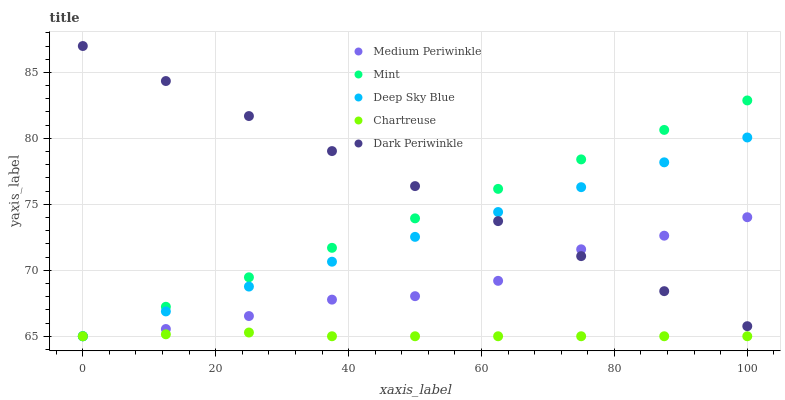Does Chartreuse have the minimum area under the curve?
Answer yes or no. Yes. Does Dark Periwinkle have the maximum area under the curve?
Answer yes or no. Yes. Does Medium Periwinkle have the minimum area under the curve?
Answer yes or no. No. Does Medium Periwinkle have the maximum area under the curve?
Answer yes or no. No. Is Deep Sky Blue the smoothest?
Answer yes or no. Yes. Is Medium Periwinkle the roughest?
Answer yes or no. Yes. Is Chartreuse the smoothest?
Answer yes or no. No. Is Chartreuse the roughest?
Answer yes or no. No. Does Mint have the lowest value?
Answer yes or no. Yes. Does Dark Periwinkle have the lowest value?
Answer yes or no. No. Does Dark Periwinkle have the highest value?
Answer yes or no. Yes. Does Medium Periwinkle have the highest value?
Answer yes or no. No. Is Chartreuse less than Dark Periwinkle?
Answer yes or no. Yes. Is Dark Periwinkle greater than Chartreuse?
Answer yes or no. Yes. Does Deep Sky Blue intersect Medium Periwinkle?
Answer yes or no. Yes. Is Deep Sky Blue less than Medium Periwinkle?
Answer yes or no. No. Is Deep Sky Blue greater than Medium Periwinkle?
Answer yes or no. No. Does Chartreuse intersect Dark Periwinkle?
Answer yes or no. No. 